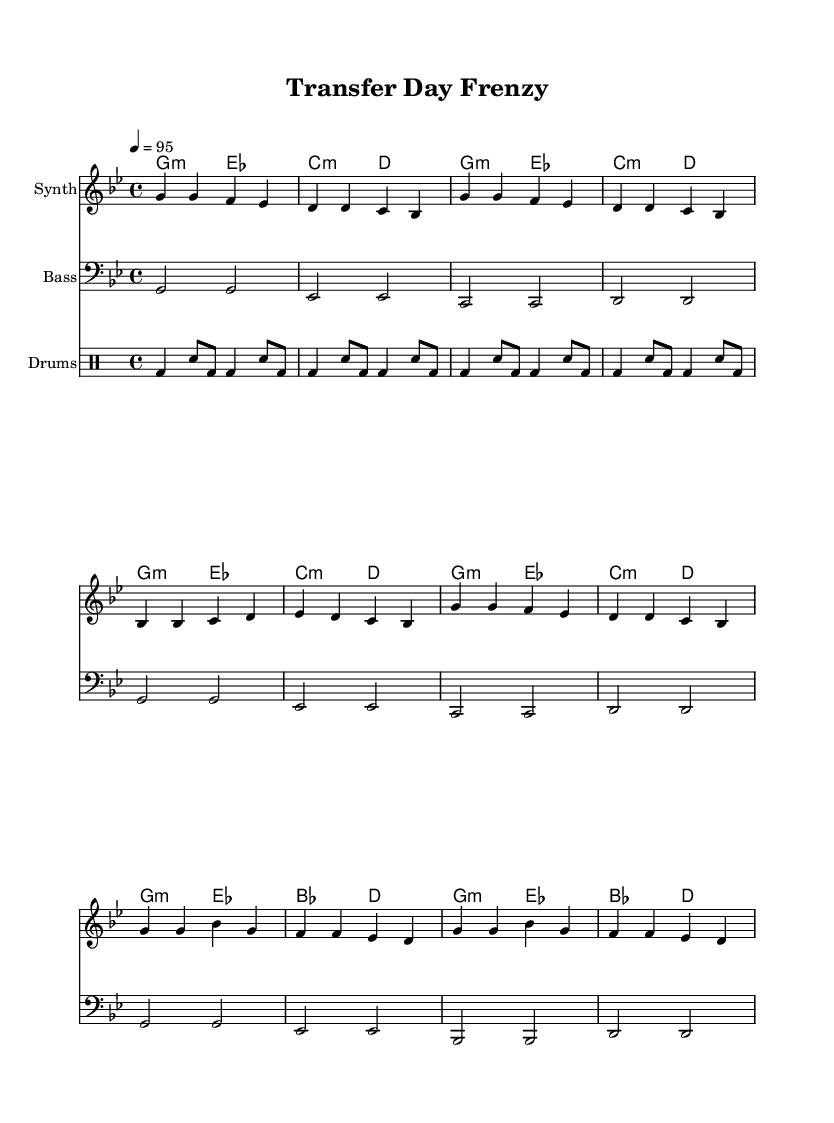What is the key signature of this music? The key signature is G minor, which contains two flats: B flat and E flat. This can be identified by looking at the key signature at the beginning of the staff.
Answer: G minor What is the time signature of this music? The time signature is 4/4, which means there are four beats in each measure and the quarter note gets one beat. This information is indicated at the beginning of the score, right after the key signature.
Answer: 4/4 What is the tempo marking for this piece? The tempo marking is quarter note equals 95, meaning that there should be 95 beats per minute. This is specified at the start of the piece alongside the time signature.
Answer: 95 How many measures are there in the verse section? The verse section consists of two measures, as indicated by the grouping of notes and the absence of bar lines after the last note of the verse. Each section is structured to fit within four beats.
Answer: 2 What instrument is designated for the melody? The instrument designated for the melody is the Synth, as indicated in the staff naming. This title is found at the beginning of the staff for the melody line.
Answer: Synth In the chorus, which note appears most frequently? The note G appears most frequently in the chorus section, as it is repeated in multiple measures. By analyzing the notes in the chorus lines, G is consistently present.
Answer: G What type of music style is this composition? This composition is categorized as rap, as it focuses on high-energy hip-hop tracks that celebrate transfer deadline day, a theme often found in rap culture.
Answer: Rap 